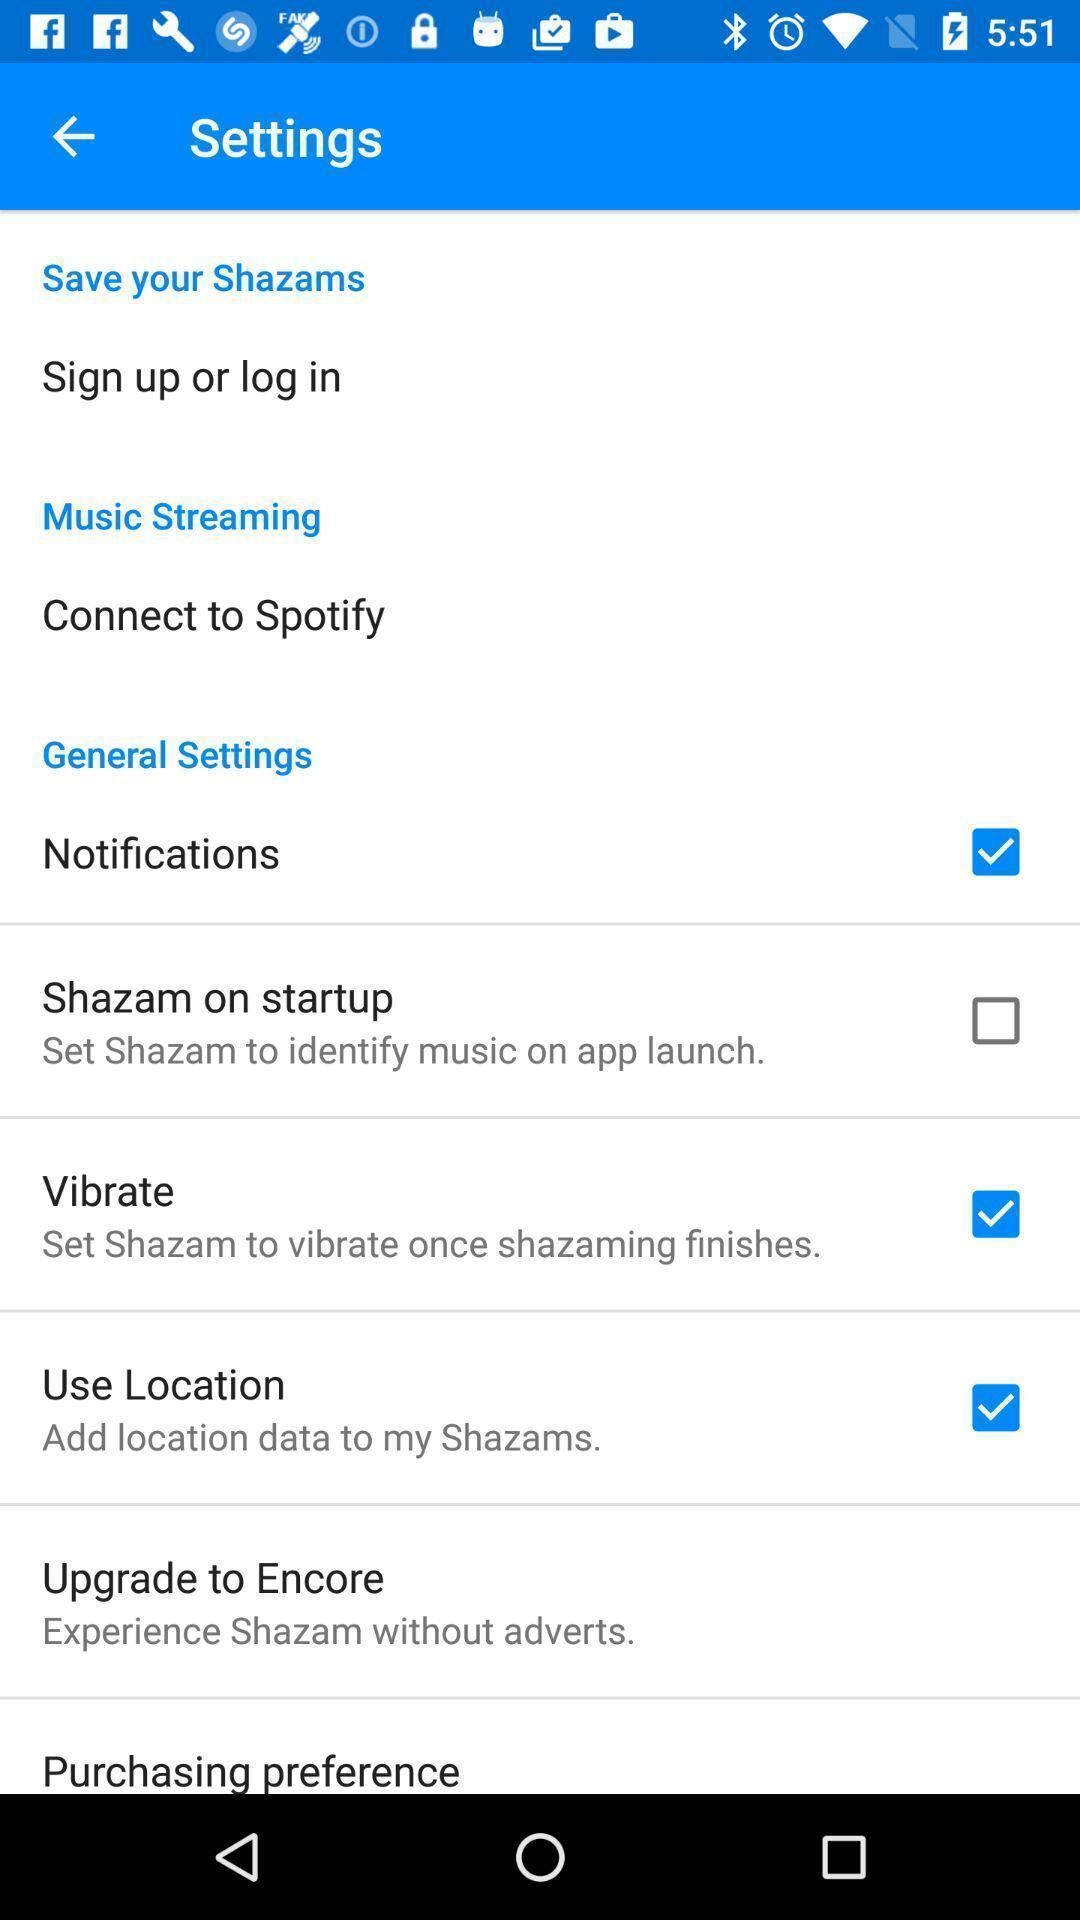Tell me about the visual elements in this screen capture. Screen displaying list of settings in app. 